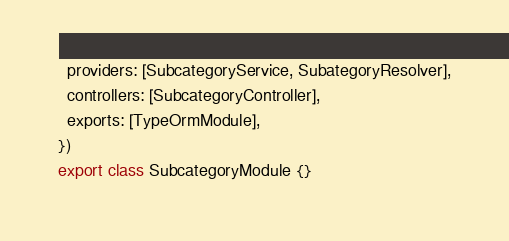<code> <loc_0><loc_0><loc_500><loc_500><_TypeScript_>  providers: [SubcategoryService, SubategoryResolver],
  controllers: [SubcategoryController],
  exports: [TypeOrmModule],
})
export class SubcategoryModule {}
</code> 